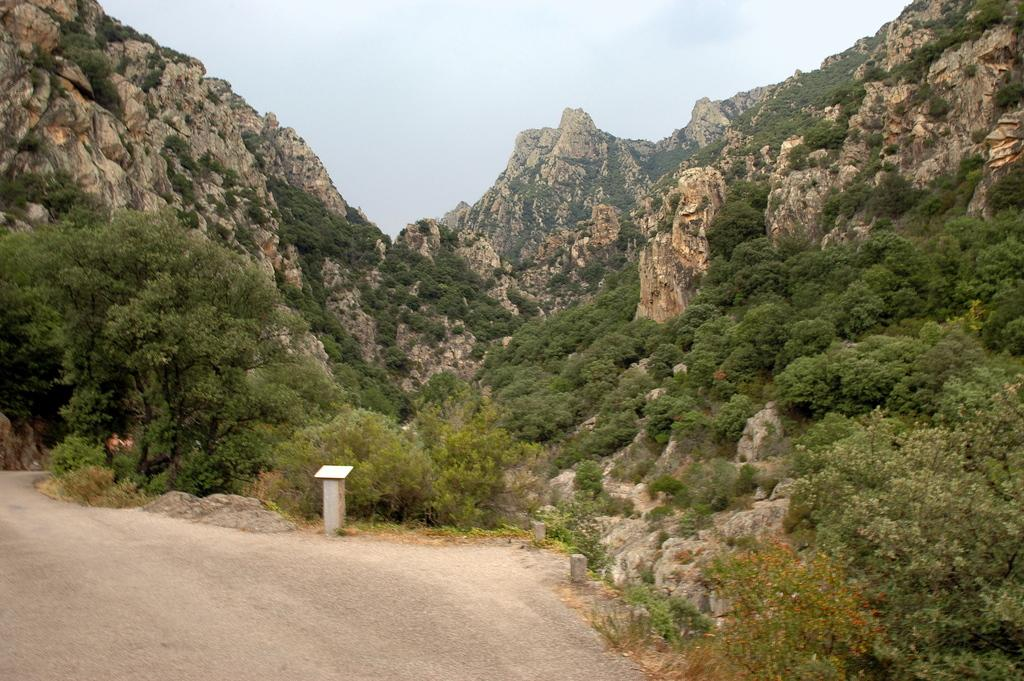What can be seen in the background of the image? There is sky in the image. What natural features are present in the image? There are mountains, trees, and plants in the image. Is there any man-made infrastructure visible in the image? Yes, there is a road in the image. What is the object on the ground in the image? The object on the ground is not specified, but it is mentioned that there is an object present. What type of string is being used to teach a class in the image? There is no string or class present in the image. On which channel can the image be viewed? The image is not a video or broadcast, so there is no channel associated with it. 